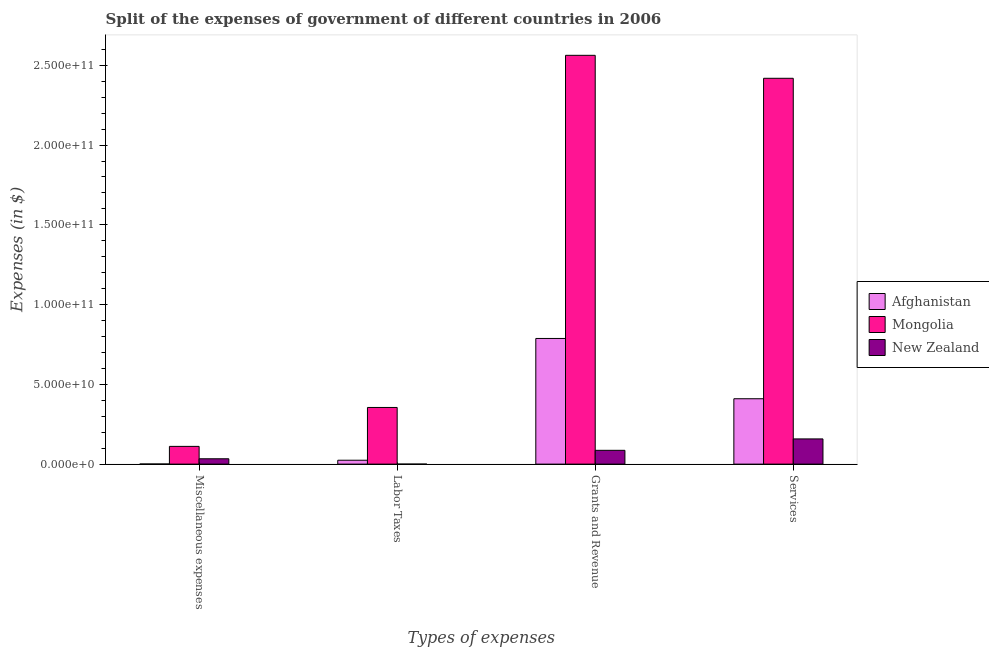How many different coloured bars are there?
Provide a succinct answer. 3. How many groups of bars are there?
Your response must be concise. 4. Are the number of bars per tick equal to the number of legend labels?
Provide a short and direct response. Yes. How many bars are there on the 3rd tick from the right?
Your response must be concise. 3. What is the label of the 1st group of bars from the left?
Provide a short and direct response. Miscellaneous expenses. What is the amount spent on labor taxes in Afghanistan?
Offer a terse response. 2.44e+09. Across all countries, what is the maximum amount spent on services?
Keep it short and to the point. 2.42e+11. Across all countries, what is the minimum amount spent on grants and revenue?
Offer a very short reply. 8.64e+09. In which country was the amount spent on services maximum?
Offer a very short reply. Mongolia. In which country was the amount spent on labor taxes minimum?
Your answer should be very brief. New Zealand. What is the total amount spent on miscellaneous expenses in the graph?
Make the answer very short. 1.45e+1. What is the difference between the amount spent on grants and revenue in Mongolia and that in New Zealand?
Your response must be concise. 2.48e+11. What is the difference between the amount spent on services in New Zealand and the amount spent on grants and revenue in Afghanistan?
Make the answer very short. -6.30e+1. What is the average amount spent on miscellaneous expenses per country?
Provide a succinct answer. 4.85e+09. What is the difference between the amount spent on services and amount spent on miscellaneous expenses in New Zealand?
Ensure brevity in your answer.  1.24e+1. What is the ratio of the amount spent on miscellaneous expenses in Mongolia to that in Afghanistan?
Keep it short and to the point. 162.19. Is the amount spent on labor taxes in New Zealand less than that in Mongolia?
Keep it short and to the point. Yes. What is the difference between the highest and the second highest amount spent on miscellaneous expenses?
Give a very brief answer. 7.76e+09. What is the difference between the highest and the lowest amount spent on services?
Make the answer very short. 2.26e+11. In how many countries, is the amount spent on services greater than the average amount spent on services taken over all countries?
Offer a terse response. 1. What does the 1st bar from the left in Labor Taxes represents?
Your response must be concise. Afghanistan. What does the 1st bar from the right in Services represents?
Ensure brevity in your answer.  New Zealand. Is it the case that in every country, the sum of the amount spent on miscellaneous expenses and amount spent on labor taxes is greater than the amount spent on grants and revenue?
Keep it short and to the point. No. How many countries are there in the graph?
Offer a very short reply. 3. Are the values on the major ticks of Y-axis written in scientific E-notation?
Keep it short and to the point. Yes. Does the graph contain grids?
Offer a very short reply. No. How many legend labels are there?
Your answer should be very brief. 3. What is the title of the graph?
Make the answer very short. Split of the expenses of government of different countries in 2006. Does "Turkey" appear as one of the legend labels in the graph?
Your answer should be compact. No. What is the label or title of the X-axis?
Give a very brief answer. Types of expenses. What is the label or title of the Y-axis?
Your answer should be compact. Expenses (in $). What is the Expenses (in $) of Afghanistan in Miscellaneous expenses?
Give a very brief answer. 6.85e+07. What is the Expenses (in $) of Mongolia in Miscellaneous expenses?
Your response must be concise. 1.11e+1. What is the Expenses (in $) of New Zealand in Miscellaneous expenses?
Offer a terse response. 3.35e+09. What is the Expenses (in $) of Afghanistan in Labor Taxes?
Your answer should be very brief. 2.44e+09. What is the Expenses (in $) in Mongolia in Labor Taxes?
Provide a succinct answer. 3.55e+1. What is the Expenses (in $) of Afghanistan in Grants and Revenue?
Ensure brevity in your answer.  7.88e+1. What is the Expenses (in $) of Mongolia in Grants and Revenue?
Ensure brevity in your answer.  2.56e+11. What is the Expenses (in $) in New Zealand in Grants and Revenue?
Provide a succinct answer. 8.64e+09. What is the Expenses (in $) in Afghanistan in Services?
Your answer should be compact. 4.10e+1. What is the Expenses (in $) of Mongolia in Services?
Offer a very short reply. 2.42e+11. What is the Expenses (in $) of New Zealand in Services?
Your answer should be very brief. 1.58e+1. Across all Types of expenses, what is the maximum Expenses (in $) of Afghanistan?
Give a very brief answer. 7.88e+1. Across all Types of expenses, what is the maximum Expenses (in $) in Mongolia?
Your answer should be compact. 2.56e+11. Across all Types of expenses, what is the maximum Expenses (in $) of New Zealand?
Your answer should be compact. 1.58e+1. Across all Types of expenses, what is the minimum Expenses (in $) in Afghanistan?
Your answer should be very brief. 6.85e+07. Across all Types of expenses, what is the minimum Expenses (in $) of Mongolia?
Your answer should be very brief. 1.11e+1. Across all Types of expenses, what is the minimum Expenses (in $) in New Zealand?
Ensure brevity in your answer.  3.00e+06. What is the total Expenses (in $) in Afghanistan in the graph?
Your answer should be compact. 1.22e+11. What is the total Expenses (in $) of Mongolia in the graph?
Keep it short and to the point. 5.45e+11. What is the total Expenses (in $) of New Zealand in the graph?
Make the answer very short. 2.78e+1. What is the difference between the Expenses (in $) of Afghanistan in Miscellaneous expenses and that in Labor Taxes?
Offer a very short reply. -2.37e+09. What is the difference between the Expenses (in $) in Mongolia in Miscellaneous expenses and that in Labor Taxes?
Provide a short and direct response. -2.44e+1. What is the difference between the Expenses (in $) in New Zealand in Miscellaneous expenses and that in Labor Taxes?
Offer a very short reply. 3.35e+09. What is the difference between the Expenses (in $) of Afghanistan in Miscellaneous expenses and that in Grants and Revenue?
Offer a terse response. -7.87e+1. What is the difference between the Expenses (in $) in Mongolia in Miscellaneous expenses and that in Grants and Revenue?
Give a very brief answer. -2.45e+11. What is the difference between the Expenses (in $) in New Zealand in Miscellaneous expenses and that in Grants and Revenue?
Make the answer very short. -5.29e+09. What is the difference between the Expenses (in $) in Afghanistan in Miscellaneous expenses and that in Services?
Your answer should be compact. -4.09e+1. What is the difference between the Expenses (in $) in Mongolia in Miscellaneous expenses and that in Services?
Your answer should be compact. -2.31e+11. What is the difference between the Expenses (in $) in New Zealand in Miscellaneous expenses and that in Services?
Your answer should be compact. -1.24e+1. What is the difference between the Expenses (in $) in Afghanistan in Labor Taxes and that in Grants and Revenue?
Your response must be concise. -7.63e+1. What is the difference between the Expenses (in $) of Mongolia in Labor Taxes and that in Grants and Revenue?
Provide a short and direct response. -2.21e+11. What is the difference between the Expenses (in $) of New Zealand in Labor Taxes and that in Grants and Revenue?
Your response must be concise. -8.64e+09. What is the difference between the Expenses (in $) of Afghanistan in Labor Taxes and that in Services?
Ensure brevity in your answer.  -3.85e+1. What is the difference between the Expenses (in $) in Mongolia in Labor Taxes and that in Services?
Make the answer very short. -2.06e+11. What is the difference between the Expenses (in $) in New Zealand in Labor Taxes and that in Services?
Offer a very short reply. -1.58e+1. What is the difference between the Expenses (in $) in Afghanistan in Grants and Revenue and that in Services?
Your answer should be compact. 3.78e+1. What is the difference between the Expenses (in $) of Mongolia in Grants and Revenue and that in Services?
Make the answer very short. 1.44e+1. What is the difference between the Expenses (in $) of New Zealand in Grants and Revenue and that in Services?
Give a very brief answer. -7.16e+09. What is the difference between the Expenses (in $) of Afghanistan in Miscellaneous expenses and the Expenses (in $) of Mongolia in Labor Taxes?
Your response must be concise. -3.54e+1. What is the difference between the Expenses (in $) of Afghanistan in Miscellaneous expenses and the Expenses (in $) of New Zealand in Labor Taxes?
Give a very brief answer. 6.55e+07. What is the difference between the Expenses (in $) in Mongolia in Miscellaneous expenses and the Expenses (in $) in New Zealand in Labor Taxes?
Your answer should be compact. 1.11e+1. What is the difference between the Expenses (in $) of Afghanistan in Miscellaneous expenses and the Expenses (in $) of Mongolia in Grants and Revenue?
Provide a succinct answer. -2.56e+11. What is the difference between the Expenses (in $) of Afghanistan in Miscellaneous expenses and the Expenses (in $) of New Zealand in Grants and Revenue?
Make the answer very short. -8.57e+09. What is the difference between the Expenses (in $) of Mongolia in Miscellaneous expenses and the Expenses (in $) of New Zealand in Grants and Revenue?
Make the answer very short. 2.47e+09. What is the difference between the Expenses (in $) in Afghanistan in Miscellaneous expenses and the Expenses (in $) in Mongolia in Services?
Ensure brevity in your answer.  -2.42e+11. What is the difference between the Expenses (in $) in Afghanistan in Miscellaneous expenses and the Expenses (in $) in New Zealand in Services?
Provide a succinct answer. -1.57e+1. What is the difference between the Expenses (in $) in Mongolia in Miscellaneous expenses and the Expenses (in $) in New Zealand in Services?
Provide a short and direct response. -4.68e+09. What is the difference between the Expenses (in $) in Afghanistan in Labor Taxes and the Expenses (in $) in Mongolia in Grants and Revenue?
Make the answer very short. -2.54e+11. What is the difference between the Expenses (in $) of Afghanistan in Labor Taxes and the Expenses (in $) of New Zealand in Grants and Revenue?
Keep it short and to the point. -6.20e+09. What is the difference between the Expenses (in $) in Mongolia in Labor Taxes and the Expenses (in $) in New Zealand in Grants and Revenue?
Your response must be concise. 2.69e+1. What is the difference between the Expenses (in $) in Afghanistan in Labor Taxes and the Expenses (in $) in Mongolia in Services?
Offer a terse response. -2.39e+11. What is the difference between the Expenses (in $) in Afghanistan in Labor Taxes and the Expenses (in $) in New Zealand in Services?
Your response must be concise. -1.34e+1. What is the difference between the Expenses (in $) in Mongolia in Labor Taxes and the Expenses (in $) in New Zealand in Services?
Make the answer very short. 1.97e+1. What is the difference between the Expenses (in $) in Afghanistan in Grants and Revenue and the Expenses (in $) in Mongolia in Services?
Offer a terse response. -1.63e+11. What is the difference between the Expenses (in $) in Afghanistan in Grants and Revenue and the Expenses (in $) in New Zealand in Services?
Your answer should be compact. 6.30e+1. What is the difference between the Expenses (in $) in Mongolia in Grants and Revenue and the Expenses (in $) in New Zealand in Services?
Make the answer very short. 2.40e+11. What is the average Expenses (in $) in Afghanistan per Types of expenses?
Make the answer very short. 3.06e+1. What is the average Expenses (in $) in Mongolia per Types of expenses?
Your response must be concise. 1.36e+11. What is the average Expenses (in $) of New Zealand per Types of expenses?
Ensure brevity in your answer.  6.95e+09. What is the difference between the Expenses (in $) of Afghanistan and Expenses (in $) of Mongolia in Miscellaneous expenses?
Provide a short and direct response. -1.10e+1. What is the difference between the Expenses (in $) in Afghanistan and Expenses (in $) in New Zealand in Miscellaneous expenses?
Make the answer very short. -3.28e+09. What is the difference between the Expenses (in $) of Mongolia and Expenses (in $) of New Zealand in Miscellaneous expenses?
Your response must be concise. 7.76e+09. What is the difference between the Expenses (in $) of Afghanistan and Expenses (in $) of Mongolia in Labor Taxes?
Make the answer very short. -3.31e+1. What is the difference between the Expenses (in $) of Afghanistan and Expenses (in $) of New Zealand in Labor Taxes?
Provide a succinct answer. 2.44e+09. What is the difference between the Expenses (in $) of Mongolia and Expenses (in $) of New Zealand in Labor Taxes?
Your answer should be very brief. 3.55e+1. What is the difference between the Expenses (in $) in Afghanistan and Expenses (in $) in Mongolia in Grants and Revenue?
Your answer should be very brief. -1.77e+11. What is the difference between the Expenses (in $) of Afghanistan and Expenses (in $) of New Zealand in Grants and Revenue?
Offer a terse response. 7.01e+1. What is the difference between the Expenses (in $) of Mongolia and Expenses (in $) of New Zealand in Grants and Revenue?
Your response must be concise. 2.48e+11. What is the difference between the Expenses (in $) in Afghanistan and Expenses (in $) in Mongolia in Services?
Your response must be concise. -2.01e+11. What is the difference between the Expenses (in $) in Afghanistan and Expenses (in $) in New Zealand in Services?
Your response must be concise. 2.52e+1. What is the difference between the Expenses (in $) of Mongolia and Expenses (in $) of New Zealand in Services?
Offer a very short reply. 2.26e+11. What is the ratio of the Expenses (in $) in Afghanistan in Miscellaneous expenses to that in Labor Taxes?
Your answer should be compact. 0.03. What is the ratio of the Expenses (in $) of Mongolia in Miscellaneous expenses to that in Labor Taxes?
Provide a succinct answer. 0.31. What is the ratio of the Expenses (in $) of New Zealand in Miscellaneous expenses to that in Labor Taxes?
Your response must be concise. 1117.33. What is the ratio of the Expenses (in $) in Afghanistan in Miscellaneous expenses to that in Grants and Revenue?
Your response must be concise. 0. What is the ratio of the Expenses (in $) of Mongolia in Miscellaneous expenses to that in Grants and Revenue?
Give a very brief answer. 0.04. What is the ratio of the Expenses (in $) in New Zealand in Miscellaneous expenses to that in Grants and Revenue?
Provide a succinct answer. 0.39. What is the ratio of the Expenses (in $) in Afghanistan in Miscellaneous expenses to that in Services?
Make the answer very short. 0. What is the ratio of the Expenses (in $) in Mongolia in Miscellaneous expenses to that in Services?
Provide a short and direct response. 0.05. What is the ratio of the Expenses (in $) of New Zealand in Miscellaneous expenses to that in Services?
Provide a short and direct response. 0.21. What is the ratio of the Expenses (in $) in Afghanistan in Labor Taxes to that in Grants and Revenue?
Offer a very short reply. 0.03. What is the ratio of the Expenses (in $) of Mongolia in Labor Taxes to that in Grants and Revenue?
Make the answer very short. 0.14. What is the ratio of the Expenses (in $) of New Zealand in Labor Taxes to that in Grants and Revenue?
Offer a very short reply. 0. What is the ratio of the Expenses (in $) in Afghanistan in Labor Taxes to that in Services?
Your answer should be compact. 0.06. What is the ratio of the Expenses (in $) of Mongolia in Labor Taxes to that in Services?
Keep it short and to the point. 0.15. What is the ratio of the Expenses (in $) in New Zealand in Labor Taxes to that in Services?
Keep it short and to the point. 0. What is the ratio of the Expenses (in $) in Afghanistan in Grants and Revenue to that in Services?
Your answer should be compact. 1.92. What is the ratio of the Expenses (in $) of Mongolia in Grants and Revenue to that in Services?
Keep it short and to the point. 1.06. What is the ratio of the Expenses (in $) of New Zealand in Grants and Revenue to that in Services?
Provide a succinct answer. 0.55. What is the difference between the highest and the second highest Expenses (in $) of Afghanistan?
Your response must be concise. 3.78e+1. What is the difference between the highest and the second highest Expenses (in $) of Mongolia?
Keep it short and to the point. 1.44e+1. What is the difference between the highest and the second highest Expenses (in $) of New Zealand?
Your answer should be very brief. 7.16e+09. What is the difference between the highest and the lowest Expenses (in $) of Afghanistan?
Your response must be concise. 7.87e+1. What is the difference between the highest and the lowest Expenses (in $) of Mongolia?
Provide a succinct answer. 2.45e+11. What is the difference between the highest and the lowest Expenses (in $) of New Zealand?
Keep it short and to the point. 1.58e+1. 